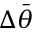<formula> <loc_0><loc_0><loc_500><loc_500>\Delta \bar { \theta }</formula> 